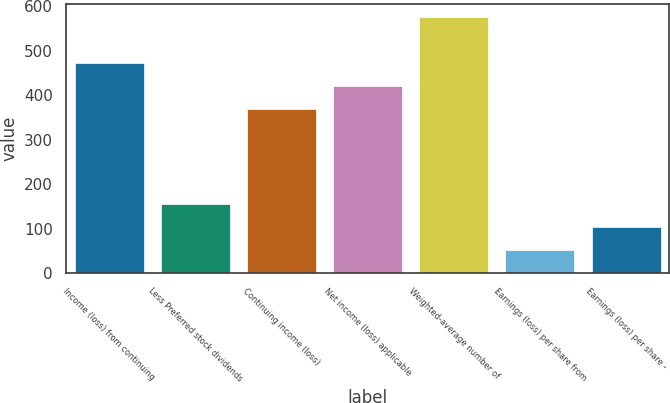Convert chart. <chart><loc_0><loc_0><loc_500><loc_500><bar_chart><fcel>Income (loss) from continuing<fcel>Less Preferred stock dividends<fcel>Continuing income (loss)<fcel>Net income (loss) applicable<fcel>Weighted-average number of<fcel>Earnings (loss) per share from<fcel>Earnings (loss) per share -<nl><fcel>472.32<fcel>155.86<fcel>368.76<fcel>420.54<fcel>575.88<fcel>52.3<fcel>104.08<nl></chart> 